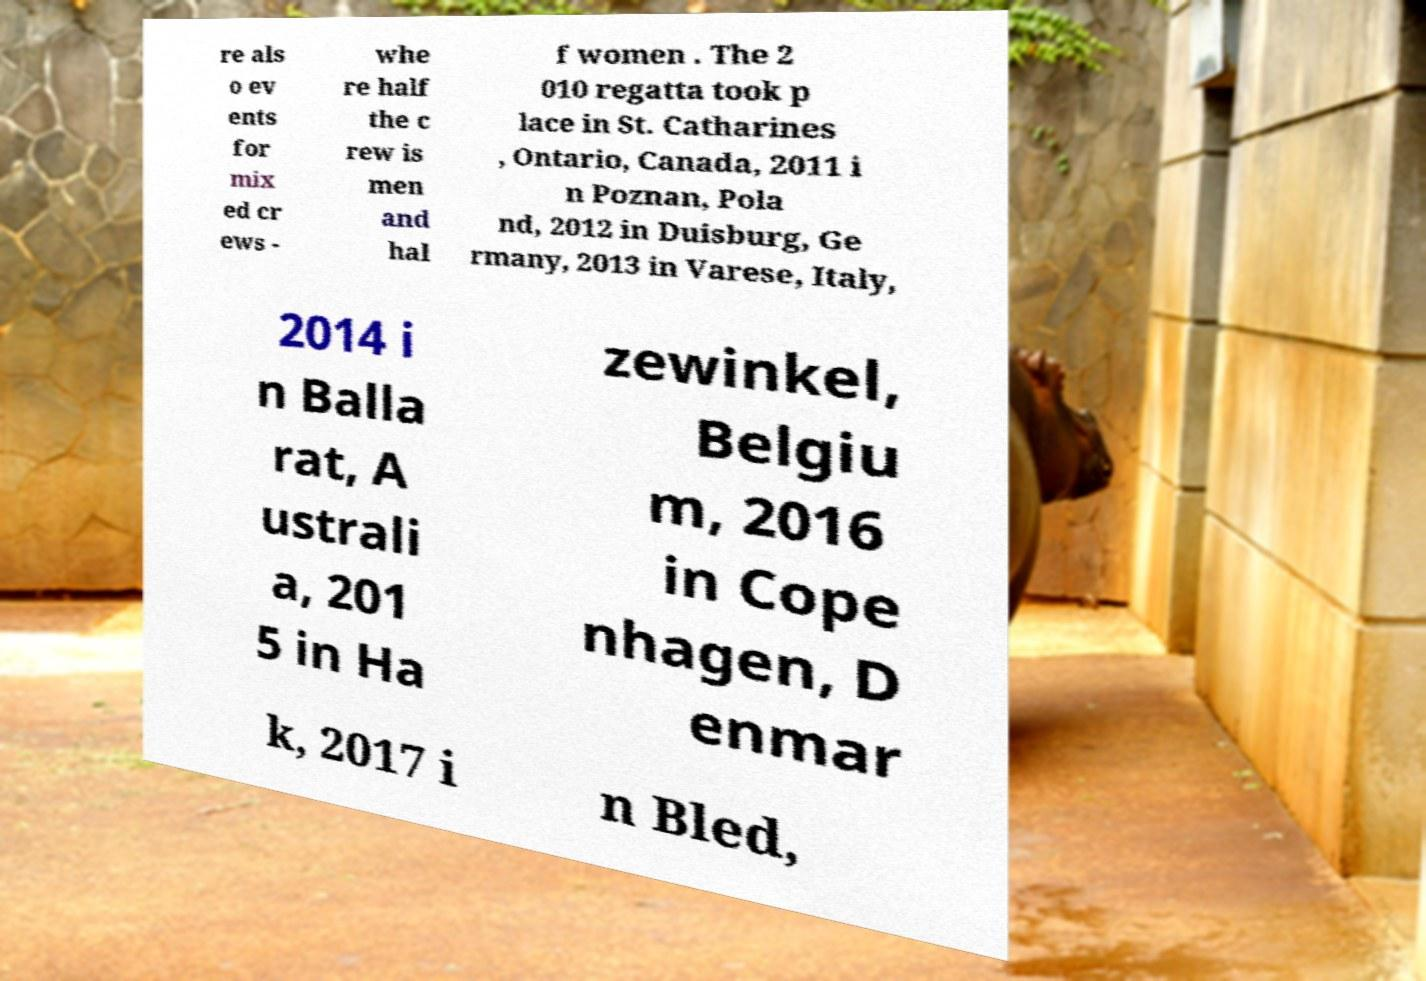I need the written content from this picture converted into text. Can you do that? re als o ev ents for mix ed cr ews - whe re half the c rew is men and hal f women . The 2 010 regatta took p lace in St. Catharines , Ontario, Canada, 2011 i n Poznan, Pola nd, 2012 in Duisburg, Ge rmany, 2013 in Varese, Italy, 2014 i n Balla rat, A ustrali a, 201 5 in Ha zewinkel, Belgiu m, 2016 in Cope nhagen, D enmar k, 2017 i n Bled, 